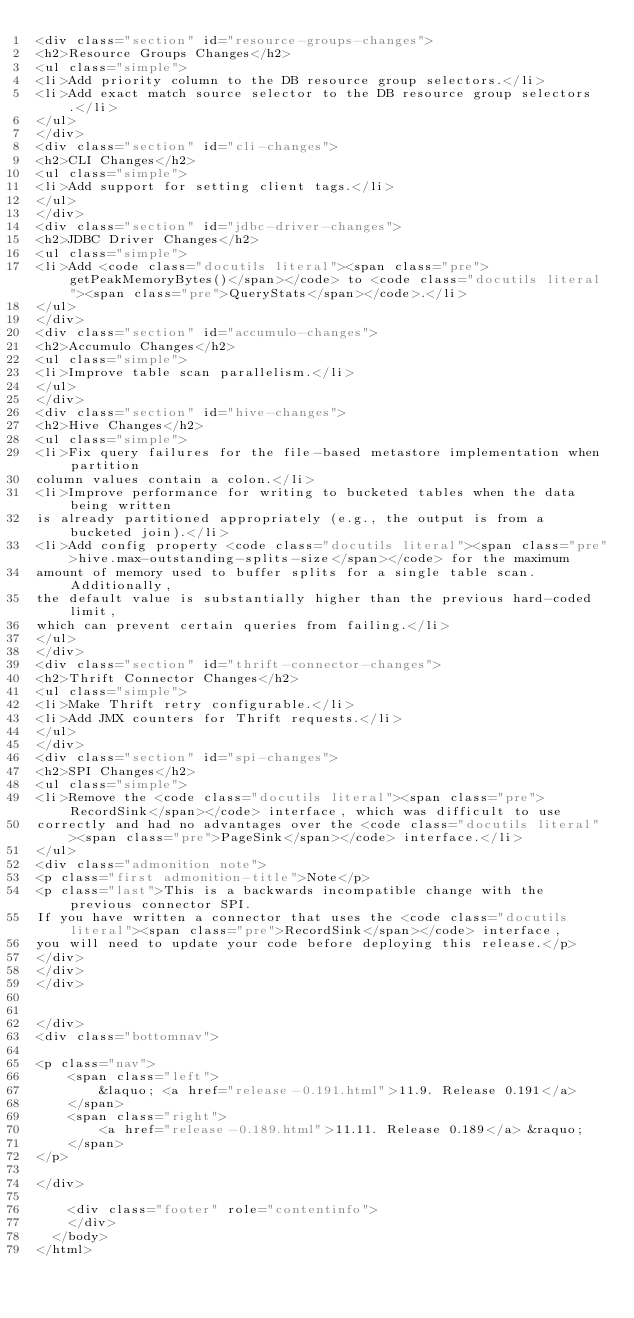Convert code to text. <code><loc_0><loc_0><loc_500><loc_500><_HTML_><div class="section" id="resource-groups-changes">
<h2>Resource Groups Changes</h2>
<ul class="simple">
<li>Add priority column to the DB resource group selectors.</li>
<li>Add exact match source selector to the DB resource group selectors.</li>
</ul>
</div>
<div class="section" id="cli-changes">
<h2>CLI Changes</h2>
<ul class="simple">
<li>Add support for setting client tags.</li>
</ul>
</div>
<div class="section" id="jdbc-driver-changes">
<h2>JDBC Driver Changes</h2>
<ul class="simple">
<li>Add <code class="docutils literal"><span class="pre">getPeakMemoryBytes()</span></code> to <code class="docutils literal"><span class="pre">QueryStats</span></code>.</li>
</ul>
</div>
<div class="section" id="accumulo-changes">
<h2>Accumulo Changes</h2>
<ul class="simple">
<li>Improve table scan parallelism.</li>
</ul>
</div>
<div class="section" id="hive-changes">
<h2>Hive Changes</h2>
<ul class="simple">
<li>Fix query failures for the file-based metastore implementation when partition
column values contain a colon.</li>
<li>Improve performance for writing to bucketed tables when the data being written
is already partitioned appropriately (e.g., the output is from a bucketed join).</li>
<li>Add config property <code class="docutils literal"><span class="pre">hive.max-outstanding-splits-size</span></code> for the maximum
amount of memory used to buffer splits for a single table scan. Additionally,
the default value is substantially higher than the previous hard-coded limit,
which can prevent certain queries from failing.</li>
</ul>
</div>
<div class="section" id="thrift-connector-changes">
<h2>Thrift Connector Changes</h2>
<ul class="simple">
<li>Make Thrift retry configurable.</li>
<li>Add JMX counters for Thrift requests.</li>
</ul>
</div>
<div class="section" id="spi-changes">
<h2>SPI Changes</h2>
<ul class="simple">
<li>Remove the <code class="docutils literal"><span class="pre">RecordSink</span></code> interface, which was difficult to use
correctly and had no advantages over the <code class="docutils literal"><span class="pre">PageSink</span></code> interface.</li>
</ul>
<div class="admonition note">
<p class="first admonition-title">Note</p>
<p class="last">This is a backwards incompatible change with the previous connector SPI.
If you have written a connector that uses the <code class="docutils literal"><span class="pre">RecordSink</span></code> interface,
you will need to update your code before deploying this release.</p>
</div>
</div>
</div>


</div>
<div class="bottomnav">
    
<p class="nav">
    <span class="left">
        &laquo; <a href="release-0.191.html">11.9. Release 0.191</a>
    </span>
    <span class="right">
        <a href="release-0.189.html">11.11. Release 0.189</a> &raquo;
    </span>
</p>

</div>

    <div class="footer" role="contentinfo">
    </div>
  </body>
</html></code> 